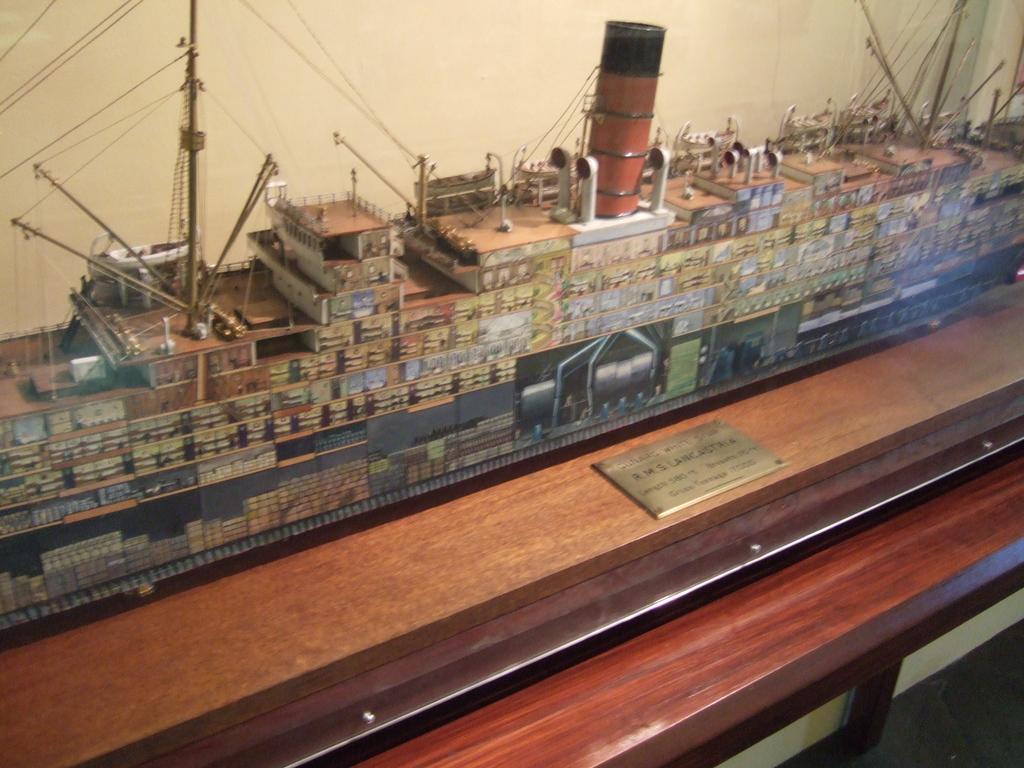Describe this image in one or two sentences. In this image I can see miniature of a ship over here. I can also see a board and on it I can see something is written. 